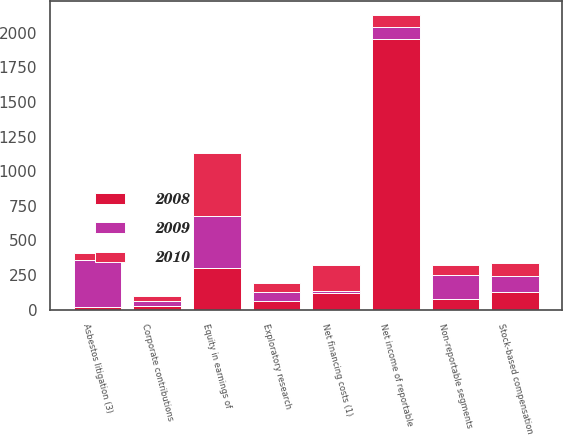Convert chart to OTSL. <chart><loc_0><loc_0><loc_500><loc_500><stacked_bar_chart><ecel><fcel>Net income of reportable<fcel>Non-reportable segments<fcel>Net financing costs (1)<fcel>Stock-based compensation<fcel>Exploratory research<fcel>Corporate contributions<fcel>Equity in earnings of<fcel>Asbestos litigation (3)<nl><fcel>2010<fcel>86<fcel>75<fcel>183<fcel>92<fcel>59<fcel>33<fcel>453<fcel>49<nl><fcel>2008<fcel>1954<fcel>80<fcel>122<fcel>127<fcel>61<fcel>27<fcel>297<fcel>20<nl><fcel>2009<fcel>86<fcel>168<fcel>15<fcel>118<fcel>69<fcel>35<fcel>382<fcel>340<nl></chart> 